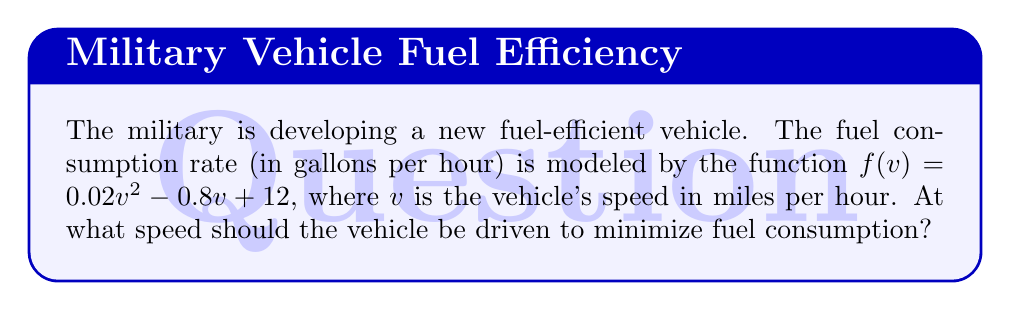What is the answer to this math problem? To find the speed that minimizes fuel consumption, we need to find the minimum point of the function $f(v)$. This can be done using calculus by following these steps:

1. Find the derivative of $f(v)$:
   $$f'(v) = 0.04v - 0.8$$

2. Set the derivative equal to zero and solve for $v$:
   $$0.04v - 0.8 = 0$$
   $$0.04v = 0.8$$
   $$v = 20$$

3. To confirm this is a minimum, check the second derivative:
   $$f''(v) = 0.04$$
   Since $f''(v) > 0$, the critical point is a minimum.

4. Therefore, the fuel consumption is minimized when the vehicle is driven at 20 miles per hour.

5. We can calculate the minimum fuel consumption rate:
   $$f(20) = 0.02(20)^2 - 0.8(20) + 12 = 8 \text{ gallons per hour}$$
Answer: 20 mph 